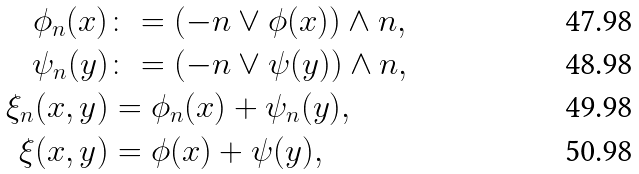Convert formula to latex. <formula><loc_0><loc_0><loc_500><loc_500>\phi _ { n } ( x ) & \colon = ( - n \lor \phi ( x ) ) \land n , \\ \psi _ { n } ( y ) & \colon = ( - n \lor \psi ( y ) ) \land n , \\ \xi _ { n } ( x , y ) & = \phi _ { n } ( x ) + \psi _ { n } ( y ) , \\ \xi ( x , y ) & = \phi ( x ) + \psi ( y ) ,</formula> 